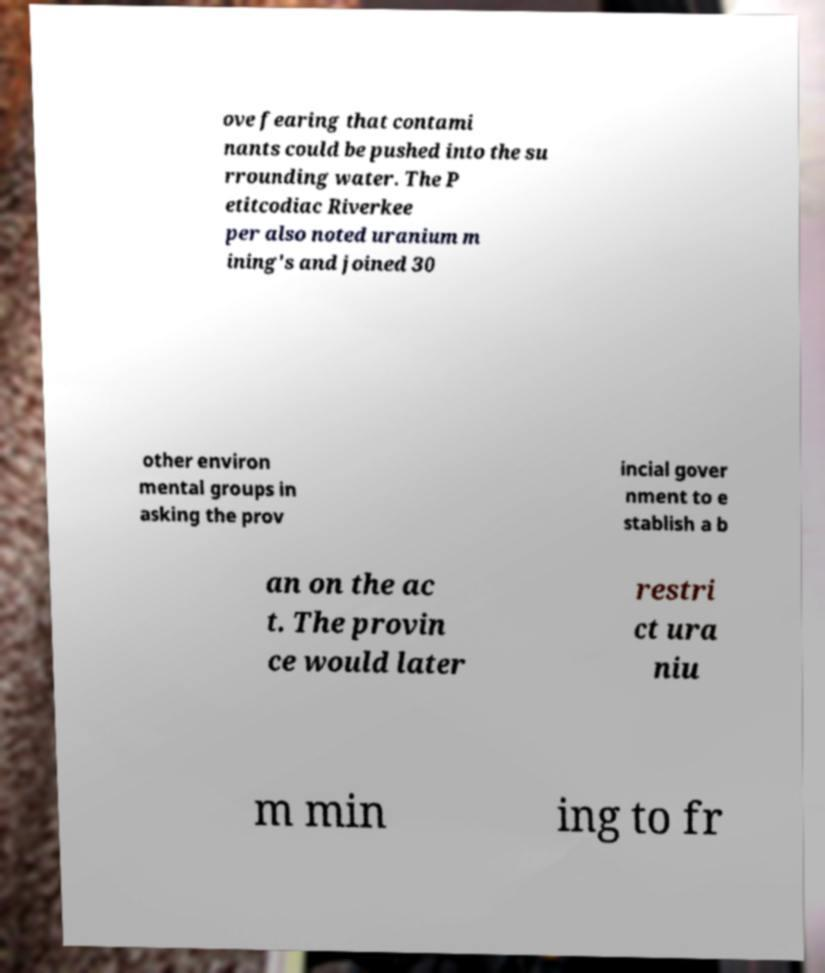Could you assist in decoding the text presented in this image and type it out clearly? ove fearing that contami nants could be pushed into the su rrounding water. The P etitcodiac Riverkee per also noted uranium m ining's and joined 30 other environ mental groups in asking the prov incial gover nment to e stablish a b an on the ac t. The provin ce would later restri ct ura niu m min ing to fr 